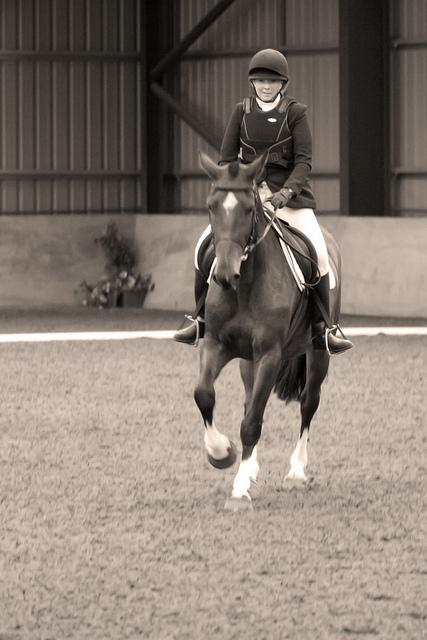Is the horse standing still?
Answer briefly. No. Does she have a pink vest?
Quick response, please. No. What is the person riding?
Quick response, please. Horse. Is the helmet for protection?
Concise answer only. Yes. 